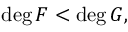<formula> <loc_0><loc_0><loc_500><loc_500>\deg F < \deg G ,</formula> 